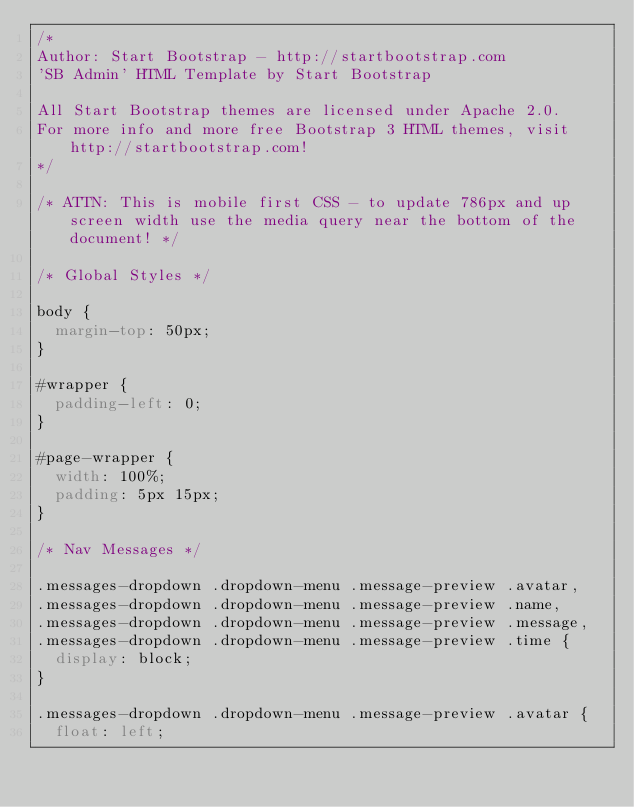Convert code to text. <code><loc_0><loc_0><loc_500><loc_500><_CSS_>/* 
Author: Start Bootstrap - http://startbootstrap.com
'SB Admin' HTML Template by Start Bootstrap

All Start Bootstrap themes are licensed under Apache 2.0. 
For more info and more free Bootstrap 3 HTML themes, visit http://startbootstrap.com!
*/

/* ATTN: This is mobile first CSS - to update 786px and up screen width use the media query near the bottom of the document! */

/* Global Styles */

body {
  margin-top: 50px;
}

#wrapper {
  padding-left: 0;
}

#page-wrapper {
  width: 100%;
  padding: 5px 15px;
}

/* Nav Messages */

.messages-dropdown .dropdown-menu .message-preview .avatar,
.messages-dropdown .dropdown-menu .message-preview .name,
.messages-dropdown .dropdown-menu .message-preview .message,
.messages-dropdown .dropdown-menu .message-preview .time {
  display: block;
}

.messages-dropdown .dropdown-menu .message-preview .avatar {
  float: left;</code> 